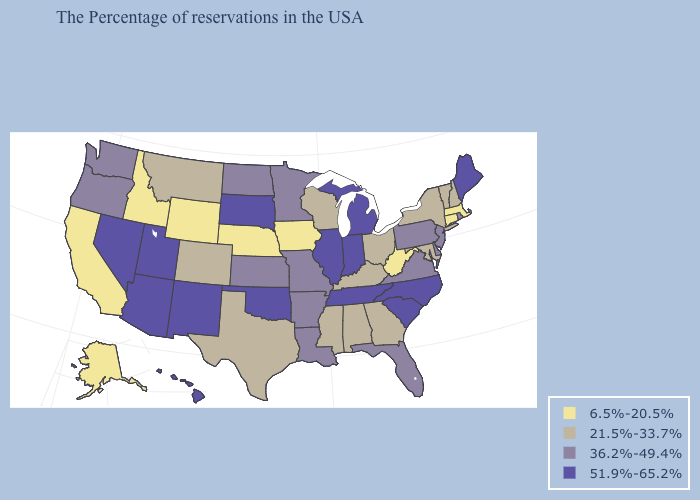What is the lowest value in the Northeast?
Be succinct. 6.5%-20.5%. Does the map have missing data?
Concise answer only. No. What is the value of Florida?
Give a very brief answer. 36.2%-49.4%. What is the highest value in the West ?
Be succinct. 51.9%-65.2%. Does Georgia have the highest value in the South?
Give a very brief answer. No. Which states have the lowest value in the West?
Give a very brief answer. Wyoming, Idaho, California, Alaska. Name the states that have a value in the range 6.5%-20.5%?
Write a very short answer. Massachusetts, Connecticut, West Virginia, Iowa, Nebraska, Wyoming, Idaho, California, Alaska. What is the value of Wisconsin?
Keep it brief. 21.5%-33.7%. Name the states that have a value in the range 21.5%-33.7%?
Quick response, please. New Hampshire, Vermont, New York, Maryland, Ohio, Georgia, Kentucky, Alabama, Wisconsin, Mississippi, Texas, Colorado, Montana. What is the value of Florida?
Write a very short answer. 36.2%-49.4%. Does Michigan have a higher value than Massachusetts?
Quick response, please. Yes. What is the value of North Carolina?
Concise answer only. 51.9%-65.2%. What is the highest value in the USA?
Write a very short answer. 51.9%-65.2%. What is the value of North Dakota?
Write a very short answer. 36.2%-49.4%. Name the states that have a value in the range 51.9%-65.2%?
Answer briefly. Maine, North Carolina, South Carolina, Michigan, Indiana, Tennessee, Illinois, Oklahoma, South Dakota, New Mexico, Utah, Arizona, Nevada, Hawaii. 